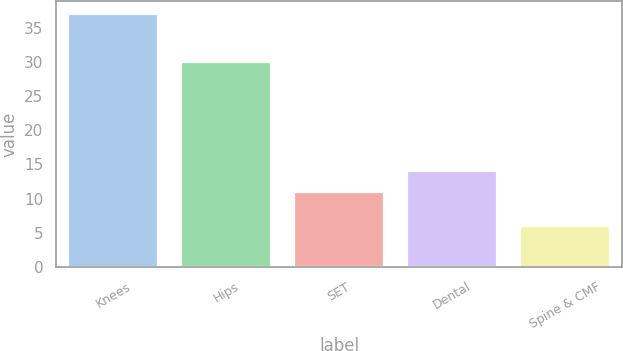Convert chart to OTSL. <chart><loc_0><loc_0><loc_500><loc_500><bar_chart><fcel>Knees<fcel>Hips<fcel>SET<fcel>Dental<fcel>Spine & CMF<nl><fcel>37<fcel>30<fcel>11<fcel>14.1<fcel>6<nl></chart> 